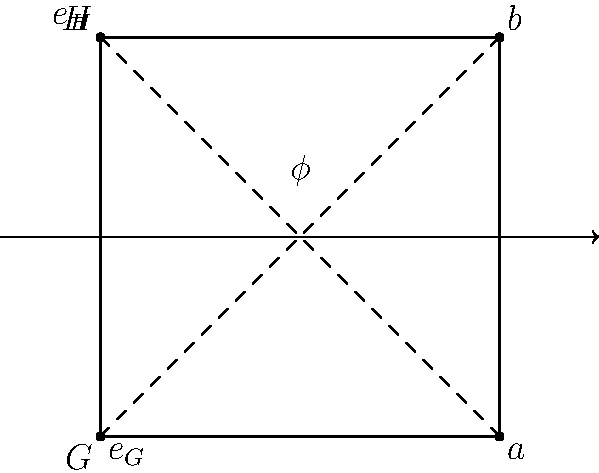Consider the group homomorphism $\phi: G \to H$ represented by the arrow diagram above. Given that $G = \{e_G, a\}$ and $H = \{e_H, b\}$ are both cyclic groups of order 2, and $\phi(e_G) = e_H$, what can we conclude about the nature of this homomorphism? Justify your answer using the properties of group homomorphisms and the given information. To analyze this group homomorphism, let's follow these steps:

1) First, recall the properties of group homomorphisms:
   - A homomorphism preserves the group operation: $\phi(xy) = \phi(x)\phi(y)$ for all $x, y \in G$
   - The identity element of $G$ must map to the identity element of $H$: $\phi(e_G) = e_H$

2) We're given that $\phi(e_G) = e_H$, which satisfies the second property.

3) Now, we need to determine $\phi(a)$. There are two possibilities: $\phi(a) = e_H$ or $\phi(a) = b$

4) Let's consider the property $\phi(a^2) = [\phi(a)]^2$:
   - In $G$, we know that $a^2 = e_G$ (since $G$ is cyclic of order 2)
   - So, $\phi(a^2) = \phi(e_G) = e_H$

5) This means that $[\phi(a)]^2 = e_H$

6) In $H$, we know that $b^2 = e_H$ and $(e_H)^2 = e_H$

7) Therefore, both possibilities for $\phi(a)$ satisfy this condition

8) However, if $\phi(a) = e_H$, then $\phi$ would map all elements of $G$ to $e_H$, making it the trivial homomorphism

9) On the other hand, if $\phi(a) = b$, then $\phi$ maps $e_G$ to $e_H$ and $a$ to $b$, preserving the group structure

10) This second case describes an isomorphism between $G$ and $H$

Given the arrow diagram and the cyclic nature of both groups, we can conclude that $\phi$ is an isomorphism, as it provides a one-to-one correspondence between the elements of $G$ and $H$ that preserves the group operation.
Answer: $\phi$ is an isomorphism 